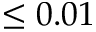Convert formula to latex. <formula><loc_0><loc_0><loc_500><loc_500>\leq 0 . 0 1</formula> 